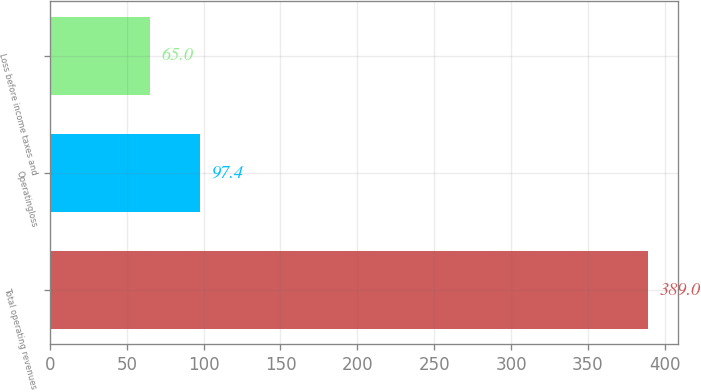Convert chart. <chart><loc_0><loc_0><loc_500><loc_500><bar_chart><fcel>Total operating revenues<fcel>Operatingloss<fcel>Loss before income taxes and<nl><fcel>389<fcel>97.4<fcel>65<nl></chart> 